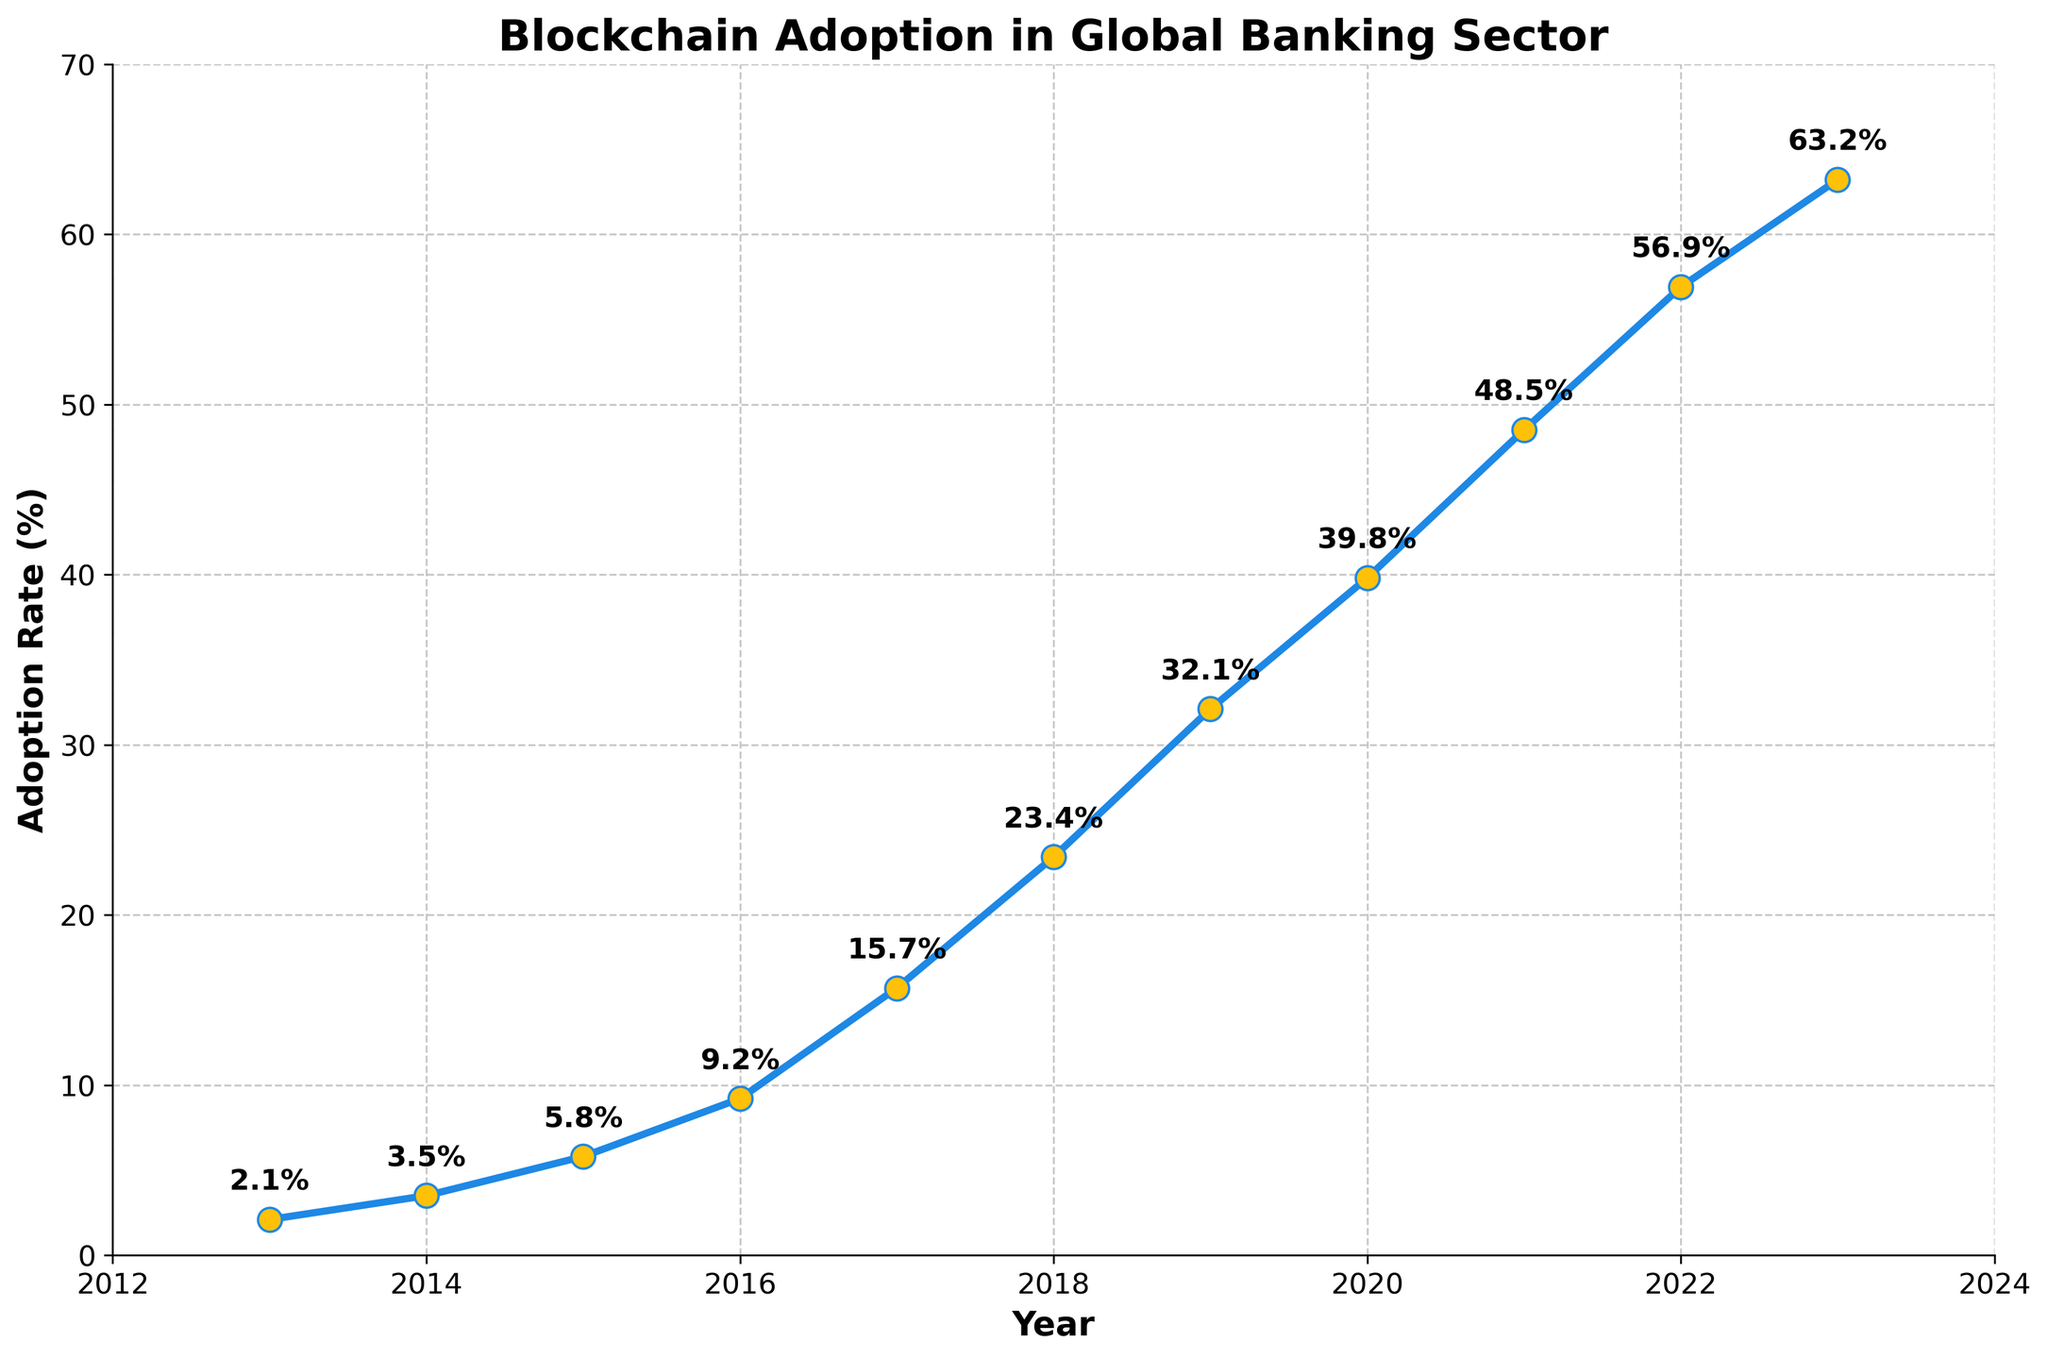When did the adoption rate first exceed 10%? Looking at the line chart, the first data point where the adoption rate passes 10% is between 2016 and 2017. The adoption rate in 2016 is 9.2%, and in 2017 it is 15.7%. Thus, it first exceeds 10% in 2017.
Answer: 2017 By how much did the adoption rate increase from 2014 to 2016? The adoption rate in 2014 is 3.5%, and in 2016 it is 9.2%. Subtract the 2014 rate from the 2016 rate: 9.2% - 3.5% = 5.7%.
Answer: 5.7% What is the average adoption rate from 2013 to 2018? Summing the adoption rates from 2013 to 2018 gives: 2.1% + 3.5% + 5.8% + 9.2% + 15.7% + 23.4% = 59.7%. Divide by the number of years (6): 59.7 / 6 = 9.95%.
Answer: 9.95% Did the adoption rate ever decrease between consecutive years? Examine the line chart and the adoption rates for each year. Since each year's rate is higher than the previous year's, the adoption rate does not decrease in any year.
Answer: No What is the overall trend of the adoption rate from 2013 to 2023? The adoption rate increases steadily each year, showing a growing interest and implementation of blockchain technology in the global banking sector.
Answer: Increasing What is the median adoption rate over the decade? Arrange the adoption rates in ascending order: 2.1%, 3.5%, 5.8%, 9.2%, 15.7%, 23.4%, 32.1%, 39.8%, 48.5%, 56.9%, 63.2%. As there are 11 data points, the median is the 6th value: 23.4%.
Answer: 23.4% What is the adoption rate in the midpoint year of the data? The midpoint year between 2013 and 2023 is 2018. The adoption rate in 2018 is 23.4%.
Answer: 23.4% 